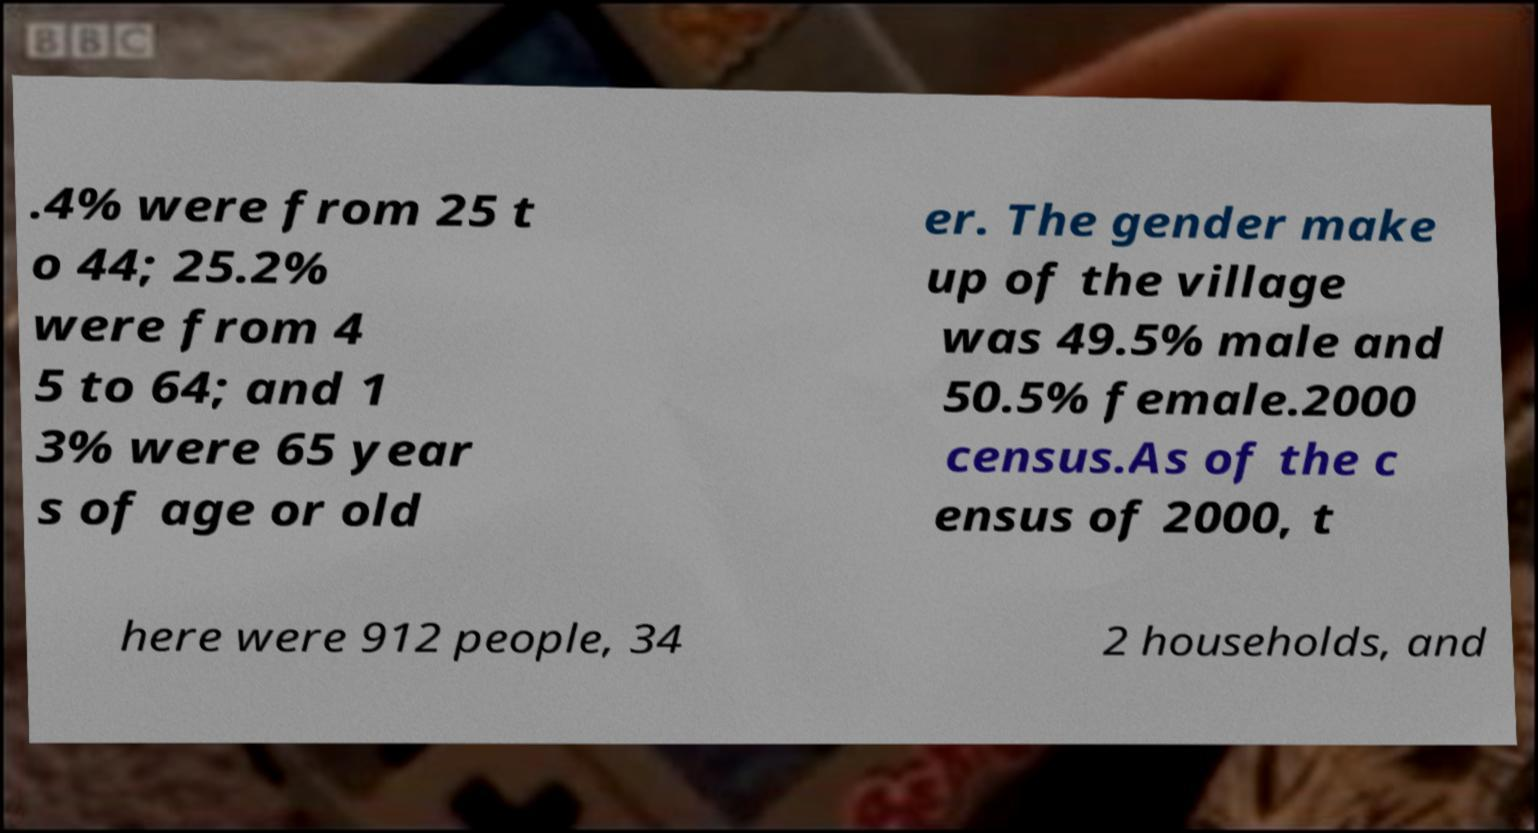Please identify and transcribe the text found in this image. .4% were from 25 t o 44; 25.2% were from 4 5 to 64; and 1 3% were 65 year s of age or old er. The gender make up of the village was 49.5% male and 50.5% female.2000 census.As of the c ensus of 2000, t here were 912 people, 34 2 households, and 